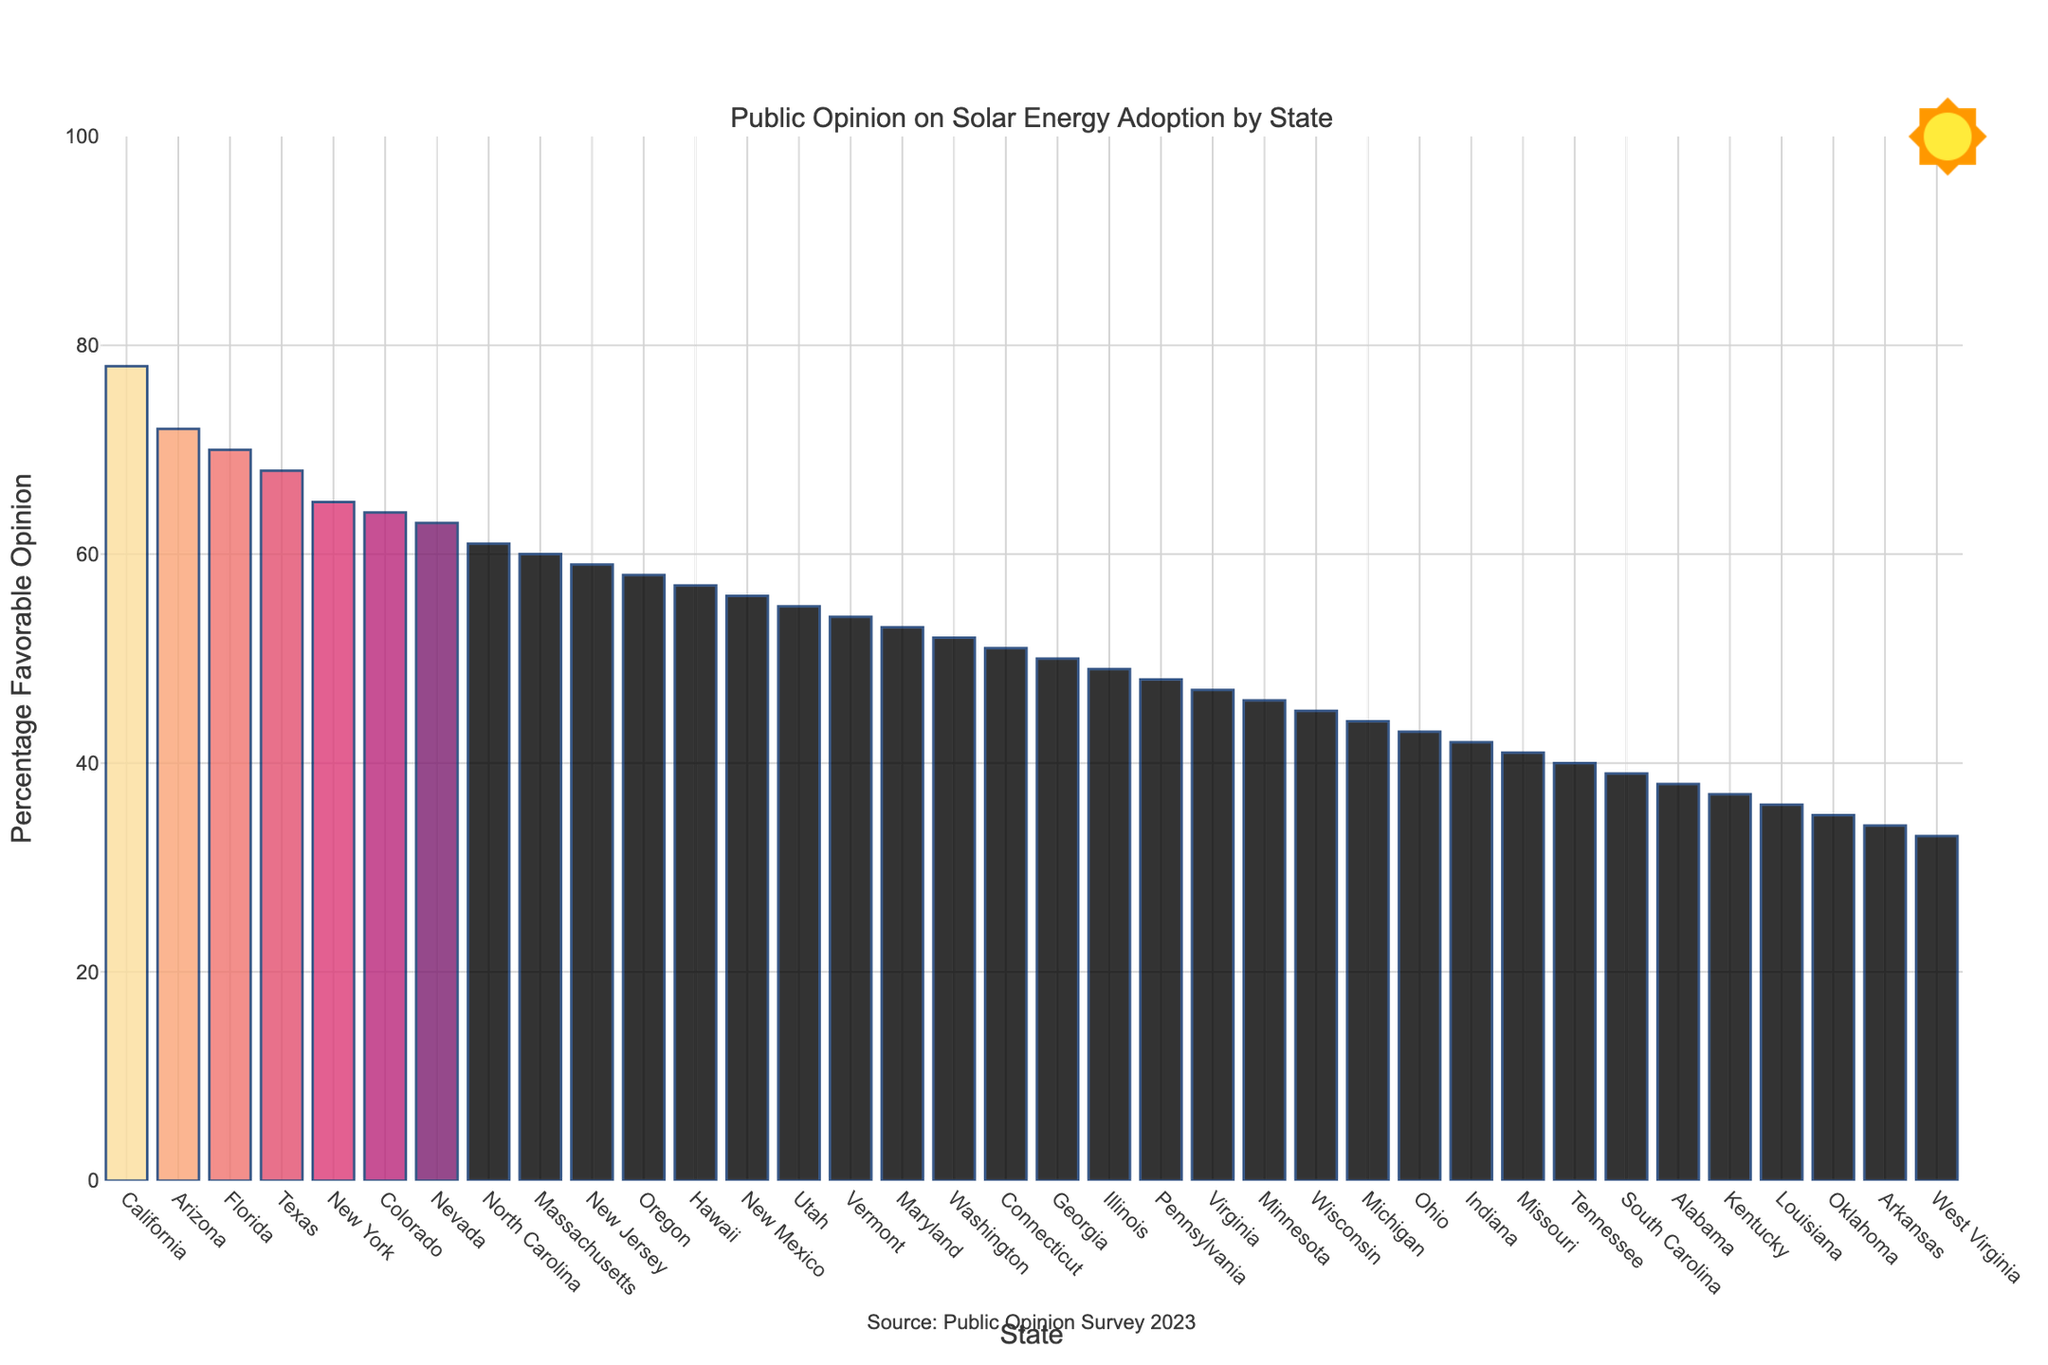What is the state with the highest favorable opinion on solar energy adoption? Look at the bar chart and identify the state with the longest bar, indicating the highest percentage of favorable opinion.
Answer: California Which state has a higher percentage of favorable opinion on solar energy adoption, Texas or Florida? Compare the heights of the bars for Texas and Florida. The bar for Florida (70%) is taller than the bar for Texas (68%).
Answer: Florida What is the difference in percentage of favorable opinion between the highest and the lowest states? Identify the highest percentage (California at 78%) and the lowest percentage (West Virginia at 33%). Subtract the lowest from the highest: 78% - 33% = 45%.
Answer: 45% What is the median favorable opinion on solar energy adoption across all the states? To find the median, list all percentages in ascending order and find the middle value. With 36 states, the middle values are the 18th and 19th percentages: 53% (Maryland) and 52% (Washington). The median is the average of these two: (53% + 52%) / 2 = 52.5%.
Answer: 52.5% Which state has a lower favorable opinion on solar energy adoption, Ohio or Indiana? Compare the heights of the bars for Ohio and Indiana. The bar for Indiana (42%) is shorter than the bar for Ohio (43%).
Answer: Indiana How many states have a favorable opinion percentage above 60%? Count the number of bars that are above the 60% mark. From California to Massachusetts, there are 10 states.
Answer: 10 What is the average percentage of favorable opinion for the top 5 states? Sum the percentages of the top 5 states (California, Arizona, Florida, Texas, and New York): 78% + 72% + 70% + 68% + 65% = 353%. Then divide by 5: 353% / 5 = 70.6%.
Answer: 70.6% What range does the favorable opinion on solar energy adoption fall within most states? Look at the distribution of the percentage bars. Most bars fall within the 40% to 70% range.
Answer: 40% to 70% Which states have an identical percentage of favorable opinion on solar energy adoption? Identify states with the same bar length. There are no states with identical percentages exactly.
Answer: None 